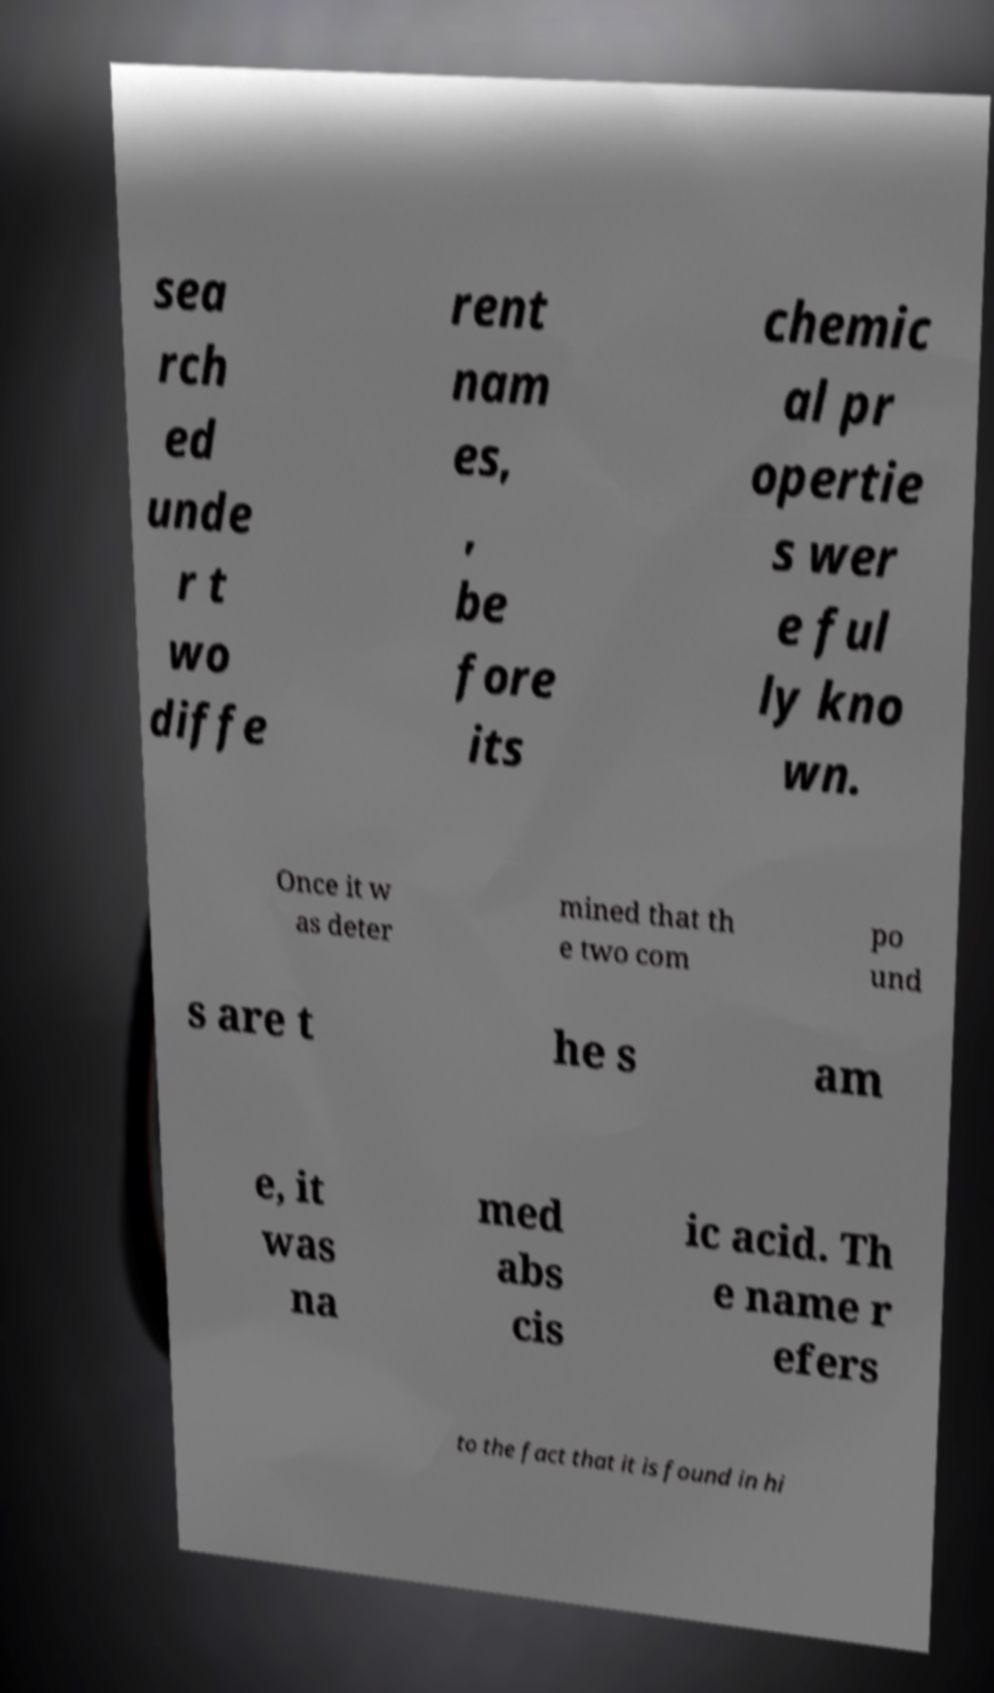There's text embedded in this image that I need extracted. Can you transcribe it verbatim? sea rch ed unde r t wo diffe rent nam es, , be fore its chemic al pr opertie s wer e ful ly kno wn. Once it w as deter mined that th e two com po und s are t he s am e, it was na med abs cis ic acid. Th e name r efers to the fact that it is found in hi 